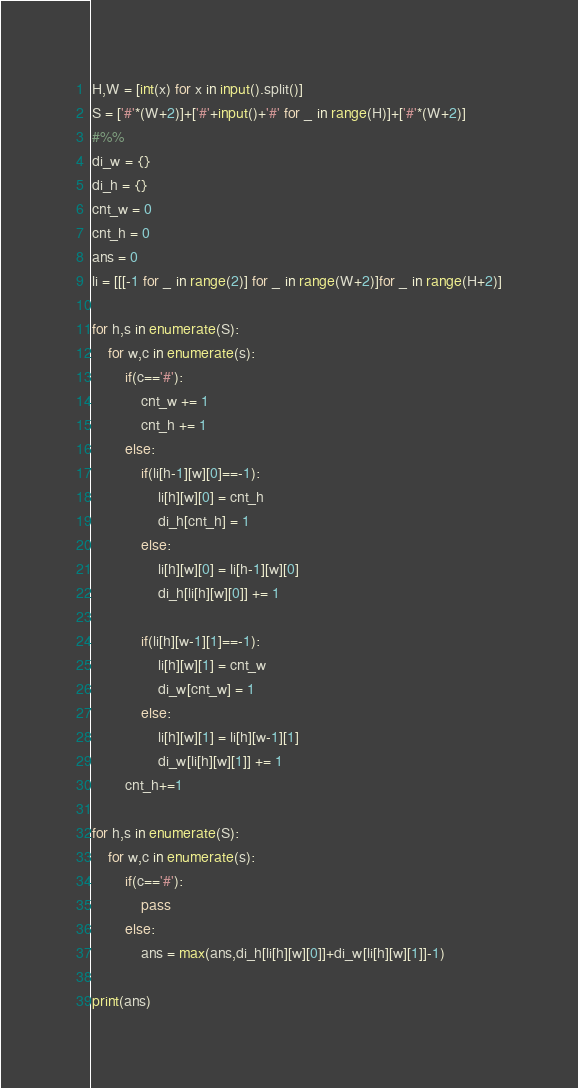Convert code to text. <code><loc_0><loc_0><loc_500><loc_500><_Python_>H,W = [int(x) for x in input().split()]
S = ['#'*(W+2)]+['#'+input()+'#' for _ in range(H)]+['#'*(W+2)]
#%%
di_w = {}
di_h = {}
cnt_w = 0
cnt_h = 0
ans = 0
li = [[[-1 for _ in range(2)] for _ in range(W+2)]for _ in range(H+2)]

for h,s in enumerate(S):
    for w,c in enumerate(s):
        if(c=='#'):
            cnt_w += 1
            cnt_h += 1
        else:
            if(li[h-1][w][0]==-1):
                li[h][w][0] = cnt_h
                di_h[cnt_h] = 1
            else:
                li[h][w][0] = li[h-1][w][0]
                di_h[li[h][w][0]] += 1

            if(li[h][w-1][1]==-1):
                li[h][w][1] = cnt_w
                di_w[cnt_w] = 1
            else:
                li[h][w][1] = li[h][w-1][1]
                di_w[li[h][w][1]] += 1
        cnt_h+=1

for h,s in enumerate(S):
    for w,c in enumerate(s):
        if(c=='#'):
            pass
        else:
            ans = max(ans,di_h[li[h][w][0]]+di_w[li[h][w][1]]-1)

print(ans)
</code> 